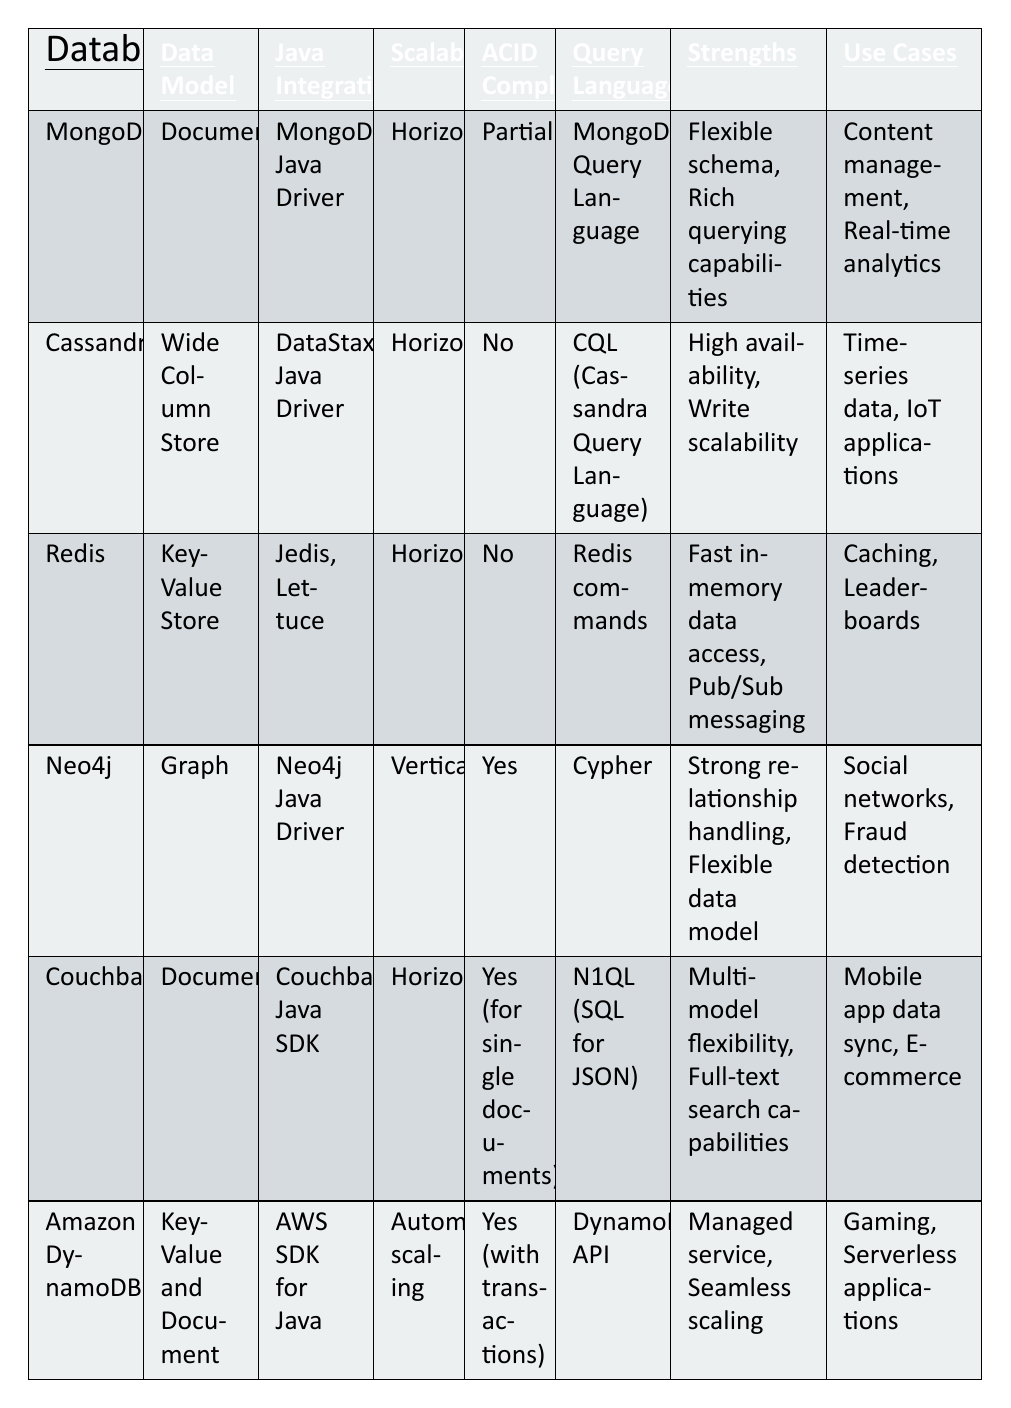What data model does Couchbase use? Couchbase is listed in the table with the "Data Model" column showing "Document." Therefore, its data model is Document.
Answer: Document Which database has a scalable architecture that is vertical? The table indicates that Neo4j has a "Scalability" type listed as "Vertical," which means it uses a vertical scaling architecture.
Answer: Neo4j Is Amazon DynamoDB ACID compliant? According to the table, Amazon DynamoDB has its "ACID Compliance" marked as "Yes (with transactions)," indicating it is ACID compliant.
Answer: Yes How many NoSQL databases listed support horizontal scalability? The table shows that MongoDB, Cassandra, Redis, Couchbase, and Amazon DynamoDB support horizontal scalability, making it a total of 5 databases.
Answer: 5 Which database uses the Cypher query language? The table specifies that Neo4j is associated with the "Query Language" Cypher, meaning it uses this query language for operations.
Answer: Neo4j Among the databases listed, which has the strength of "High availability, Write scalability"? The strengths of Cassandra include "High availability, Write scalability," indicating that it possesses these attributes.
Answer: Cassandra What is the average ACID compliance status of the NoSQL databases in the table? Counting the entries, we see 3 databases are fully ACID compliant (Neo4j, Couchbase, Amazon DynamoDB) and 3 are not (MongoDB, Cassandra, Redis), resulting in an average showing that half are compliant.
Answer: Approximately 50% compliant Which NoSQL database is best suited for time-series data applications? The Use Cases column under Cassandra lists "Time-series data," indicating it is suitable for such applications.
Answer: Cassandra If we combine the strengths of MongoDB and Redis, which features are highlighted? MongoDB highlights "Flexible schema, Rich querying capabilities," and Redis points out "Fast in-memory data access, Pub/Sub messaging" when we combine their strengths. Together, they show features of flexibility, speed, and messaging.
Answer: Flexibility, speed, messaging What are the primary use cases for Couchbase as per the table? The table specifies that Couchbase is used for "Mobile app data sync" and "E-commerce," defining its primary use cases.
Answer: Mobile app data sync, E-commerce 